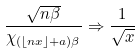<formula> <loc_0><loc_0><loc_500><loc_500>\frac { \sqrt { n \beta } } { \chi _ { ( \lfloor n x \rfloor + a ) \beta } } \Rightarrow \frac { 1 } { \sqrt { x } }</formula> 